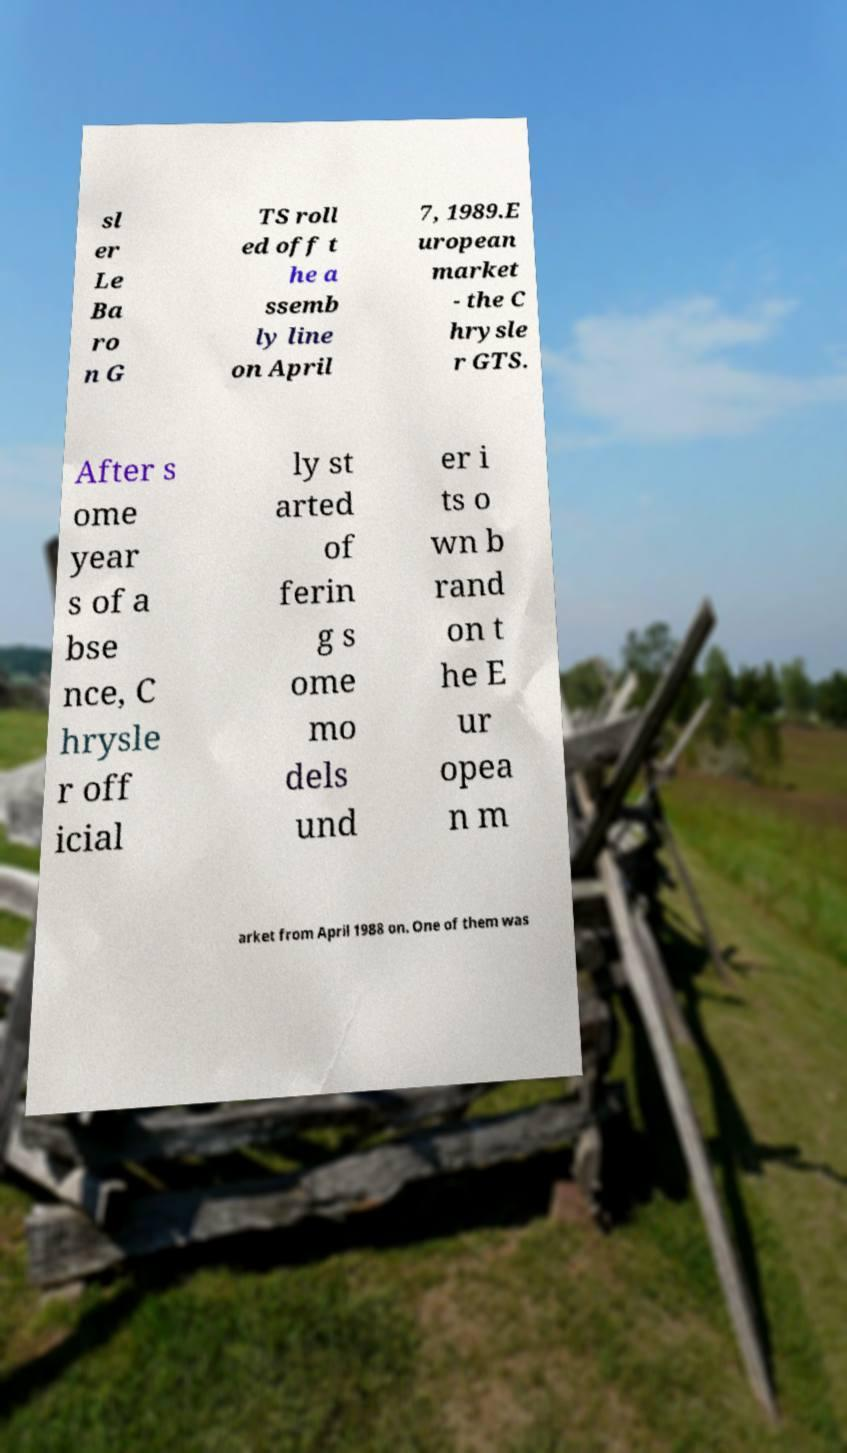Can you accurately transcribe the text from the provided image for me? sl er Le Ba ro n G TS roll ed off t he a ssemb ly line on April 7, 1989.E uropean market - the C hrysle r GTS. After s ome year s of a bse nce, C hrysle r off icial ly st arted of ferin g s ome mo dels und er i ts o wn b rand on t he E ur opea n m arket from April 1988 on. One of them was 